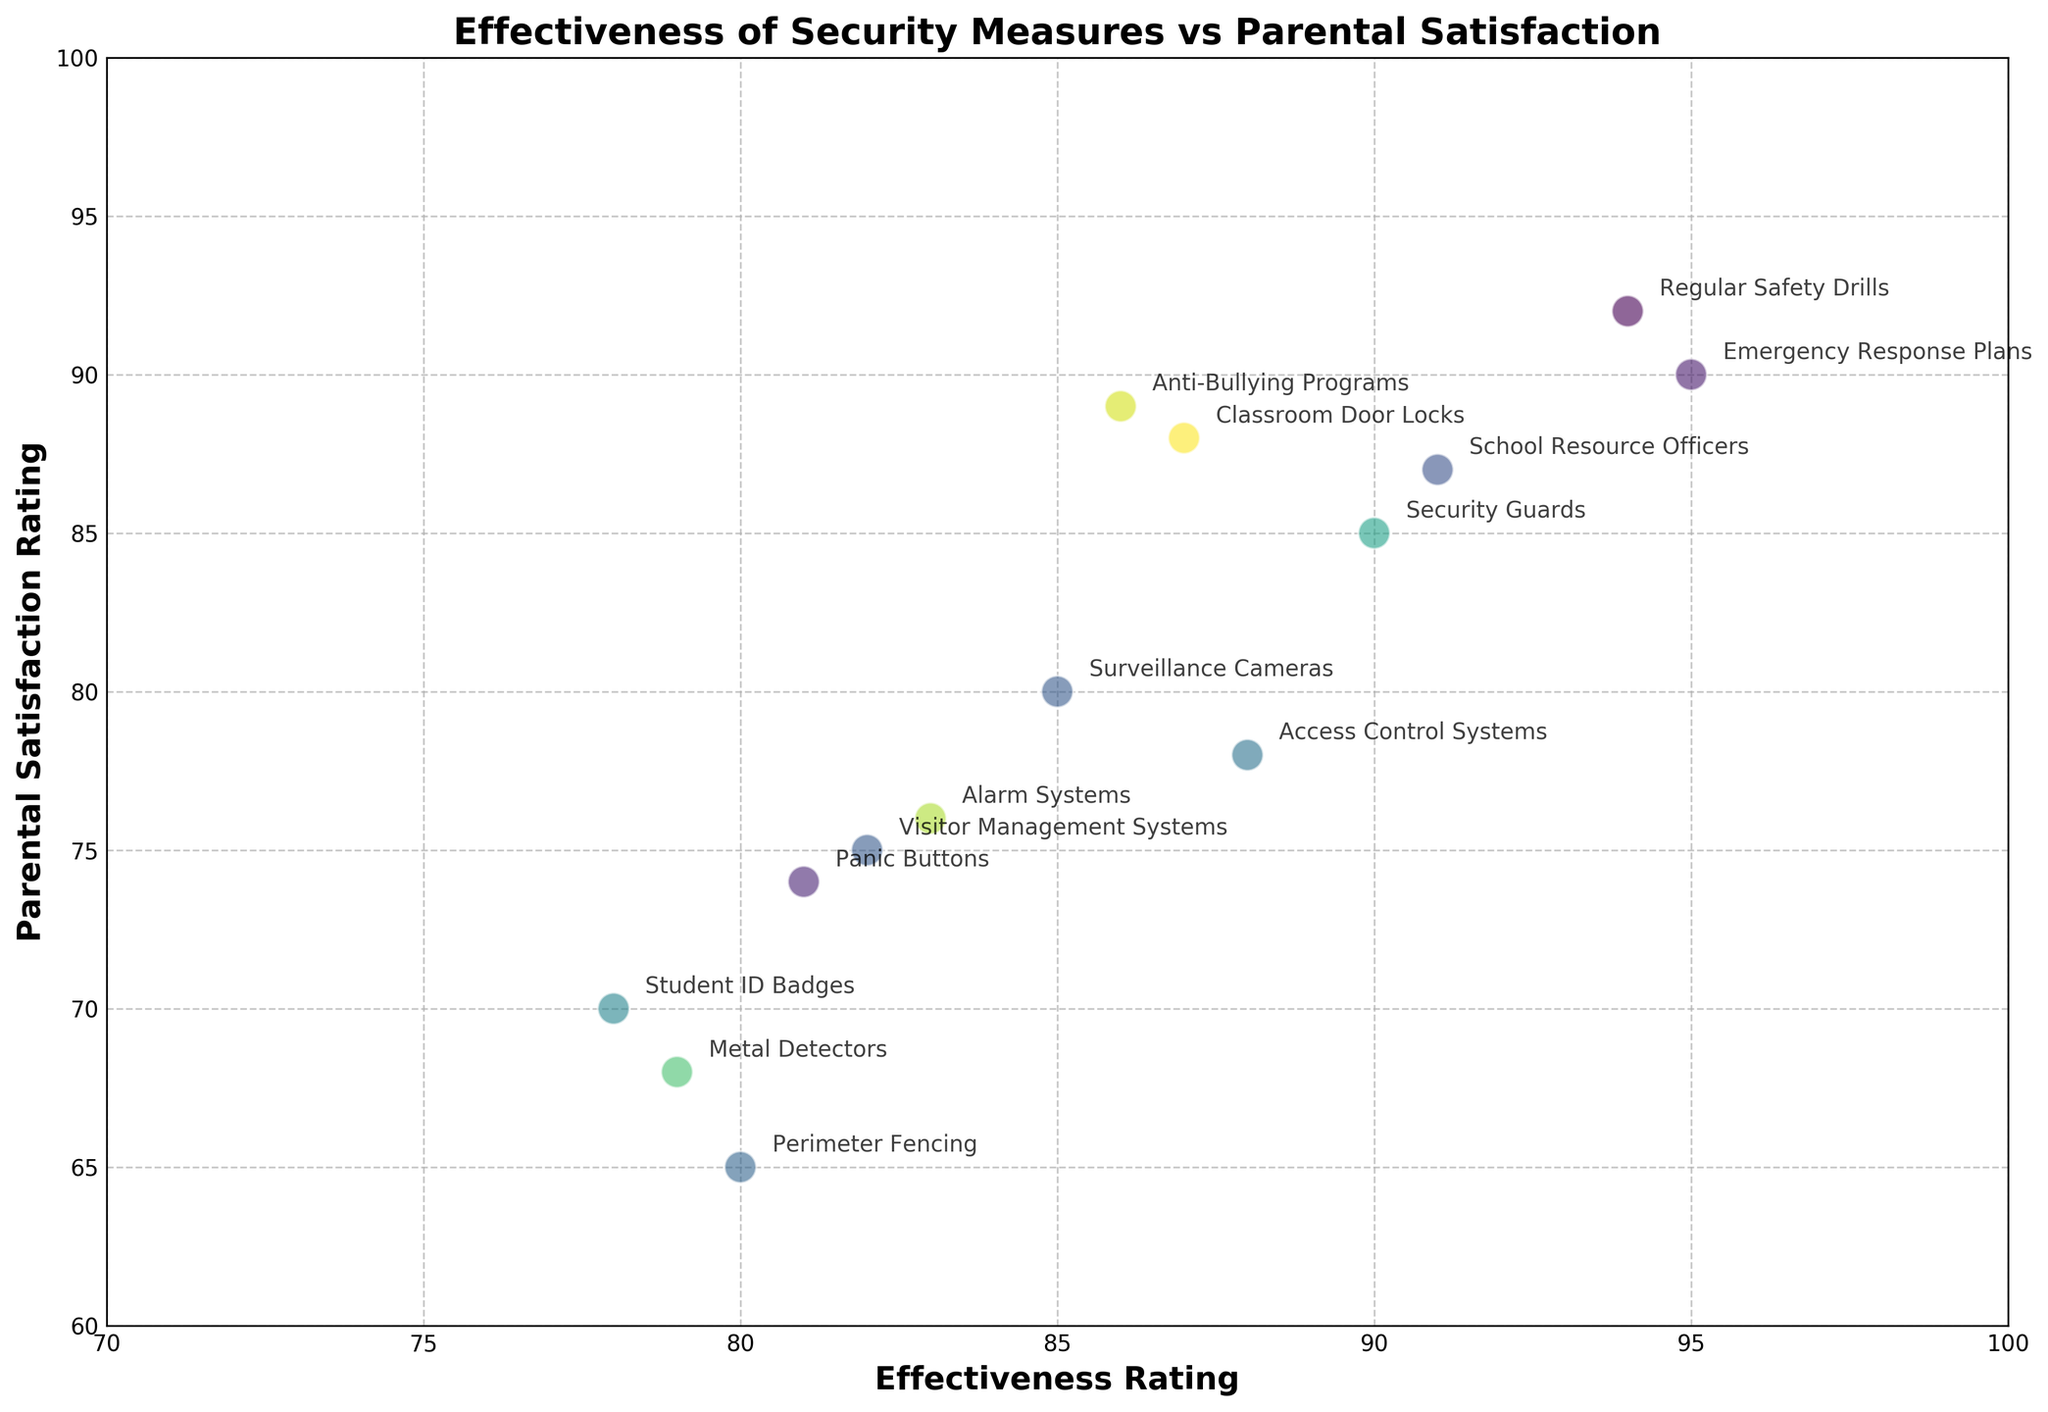Which security measure has the highest parental satisfaction rating? The security measure with the highest parental satisfaction rating is the one with the highest point on the y-axis. In this case, it is "Regular Safety Drills" with a rating of 92.
Answer: Regular Safety Drills Which security measure has the lowest effectiveness rating among those with a parental satisfaction rating above 80? First, identify security measures with parental satisfaction ratings above 80. These include: Regular Safety Drills (92), Anti-Bullying Programs (89), Classroom Door Locks (88), School Resource Officers (87), and Emergency Response Plans (90). Among these, "Classroom Door Locks" has the lowest effectiveness rating of 87.
Answer: Classroom Door Locks What is the average parental satisfaction rating for security measures with an effectiveness rating of 85 or higher? First, identify measures with an effectiveness rating of 85 or higher: Surveillance Cameras (80), Security Guards (85), Access Control Systems (78), Emergency Response Plans (90), Classroom Door Locks (88), Regular Safety Drills (92), Anti-Bullying Programs (89), Alarm Systems (76), and School Resource Officers (87). Adding the satisfaction ratings: 80 + 85 + 78 + 90 + 88 + 92 + 89 + 76 + 87 = 765. There are 9 measures, so the average is 765/9 = 85.
Answer: 85 Which security measure has the greatest discrepancy between effectiveness rating and parental satisfaction rating? To determine the greatest discrepancy, calculate the absolute difference between effectiveness and satisfaction for each measure and identify the largest value. The results are: Surveillance Cameras (5), Security Guards (5), Access Control Systems (10), Visitor Management Systems (7), Emergency Response Plans (5), Student ID Badges (8), Panic Buttons (7), Alarm Systems (7), Classroom Door Locks (1), Regular Safety Drills (2), Metal Detectors (11), School Resource Officers (4), Perimeter Fencing (15), Anti-Bullying Programs (3). The greatest discrepancy is 15 for Perimeter Fencing.
Answer: Perimeter Fencing Is there a security measure where the parental satisfaction rating is higher than its effectiveness rating? Compare each measure's satisfaction to its effectiveness to find if any satisfaction rating exceeds the effectiveness rating. "Classroom Door Locks" has a parental satisfaction rating of 88 and an effectiveness rating of 87, which means the satisfaction rating is higher.
Answer: Classroom Door Locks 